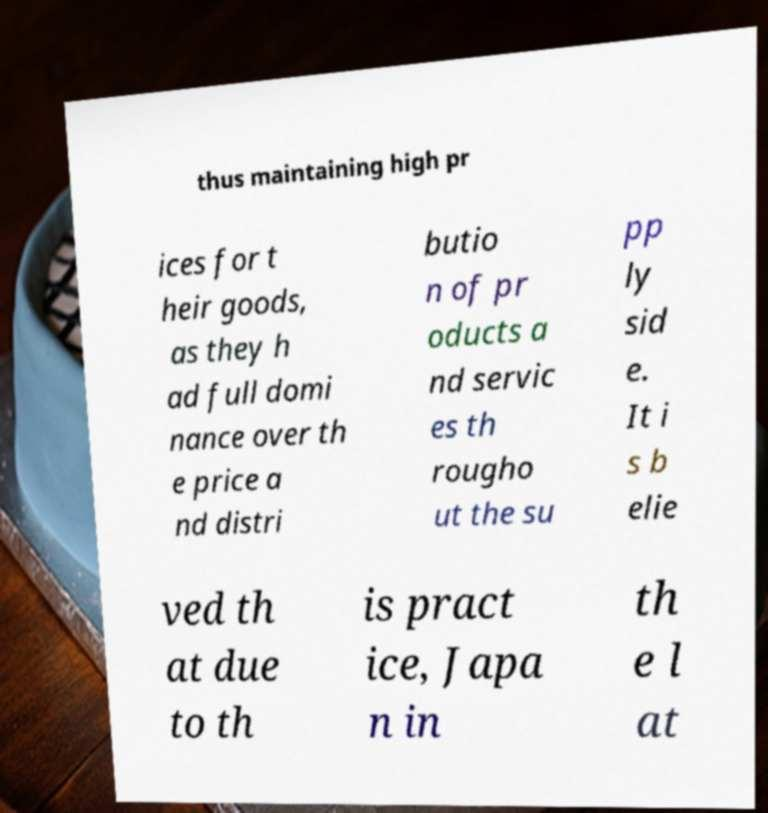Please identify and transcribe the text found in this image. thus maintaining high pr ices for t heir goods, as they h ad full domi nance over th e price a nd distri butio n of pr oducts a nd servic es th rougho ut the su pp ly sid e. It i s b elie ved th at due to th is pract ice, Japa n in th e l at 